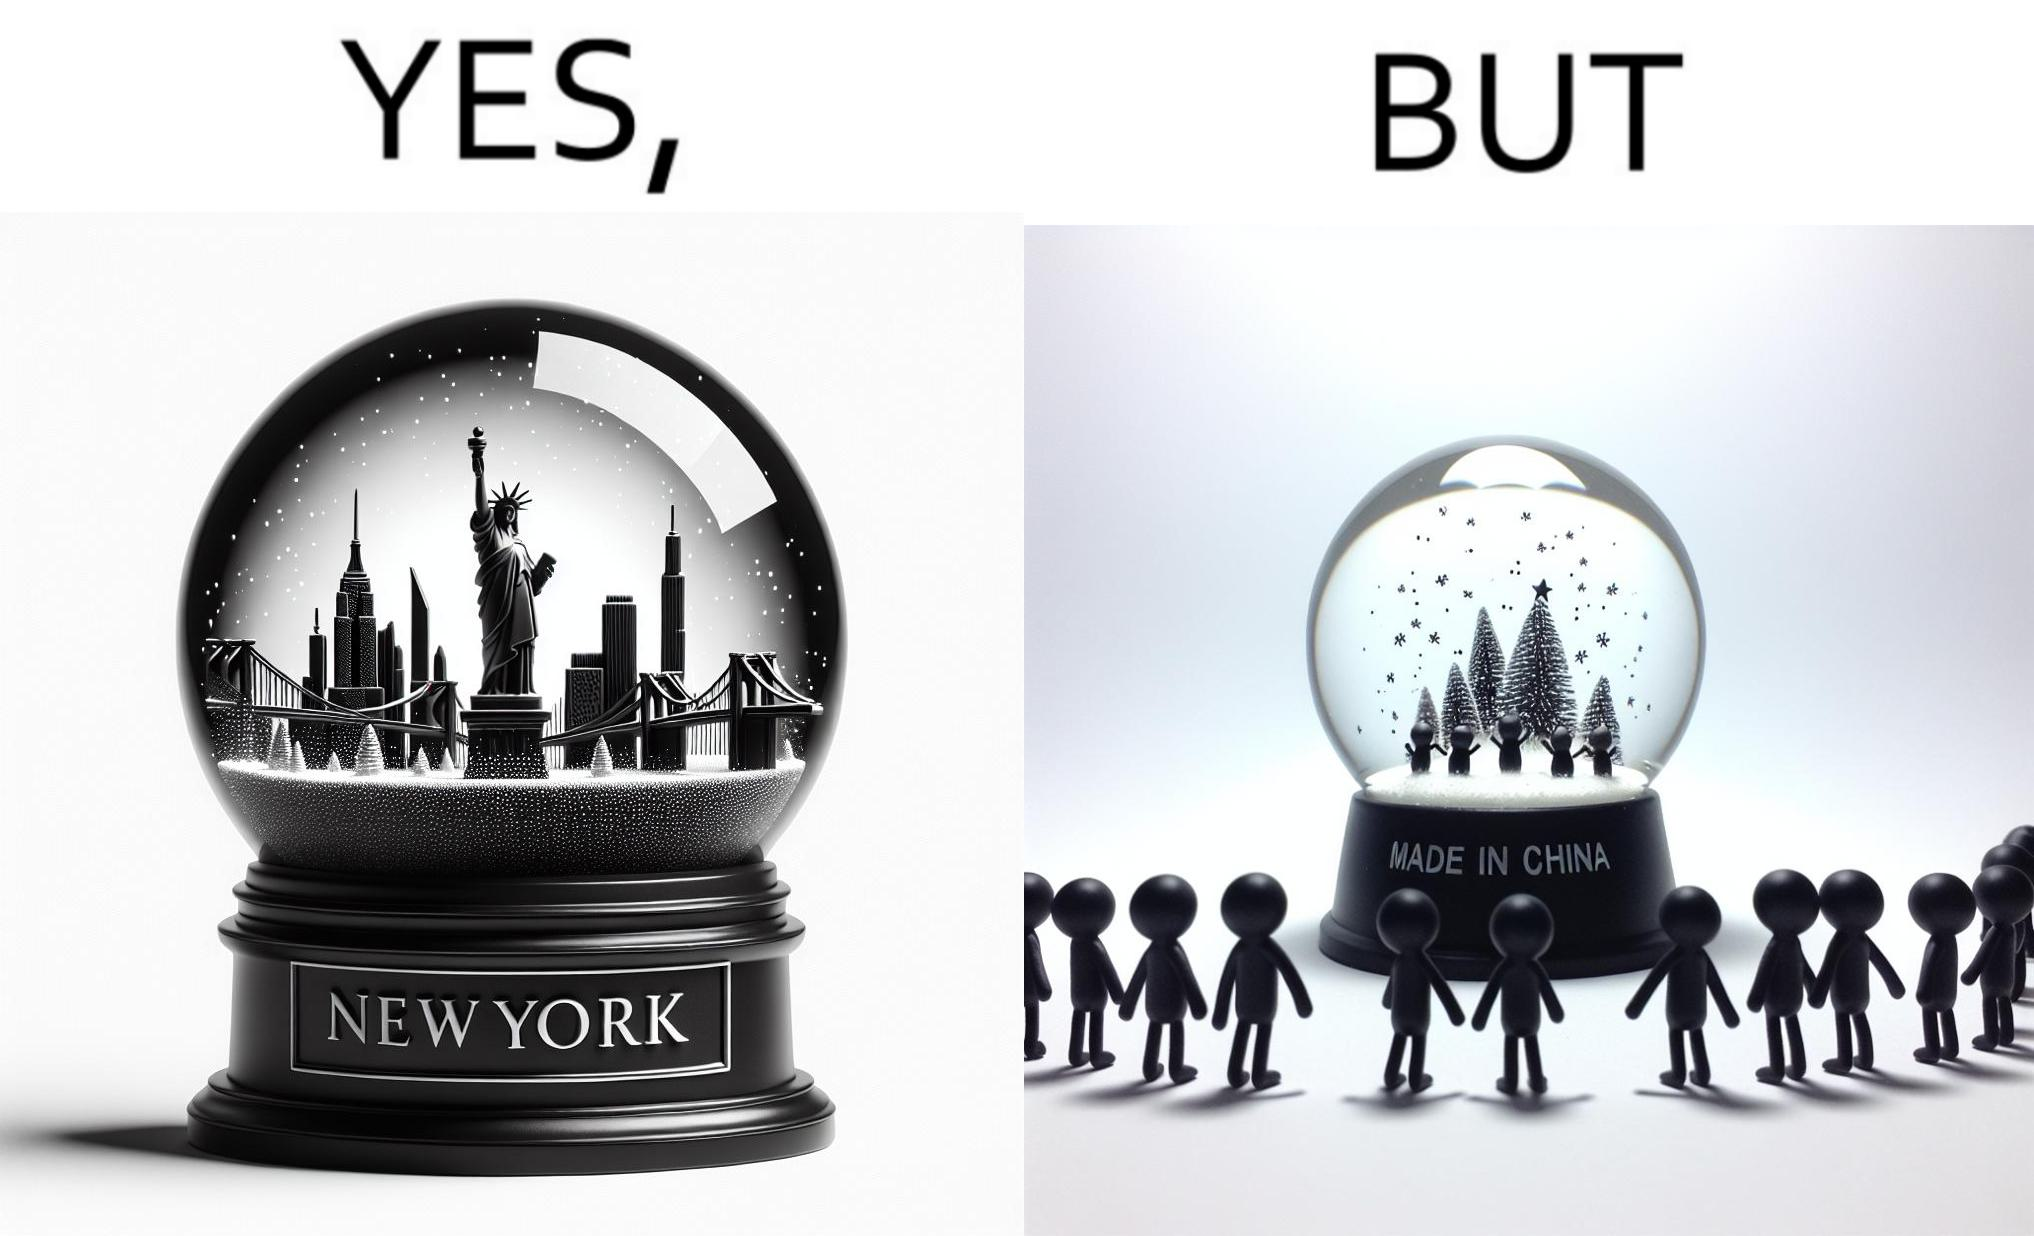Describe the satirical element in this image. The image is ironic because the snowglobe says 'New York' while it is made in China 